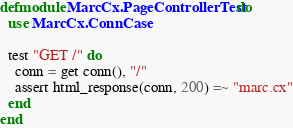<code> <loc_0><loc_0><loc_500><loc_500><_Elixir_>defmodule MarcCx.PageControllerTest do
  use MarcCx.ConnCase

  test "GET /" do
    conn = get conn(), "/"
    assert html_response(conn, 200) =~ "marc.cx"
  end
end
</code> 